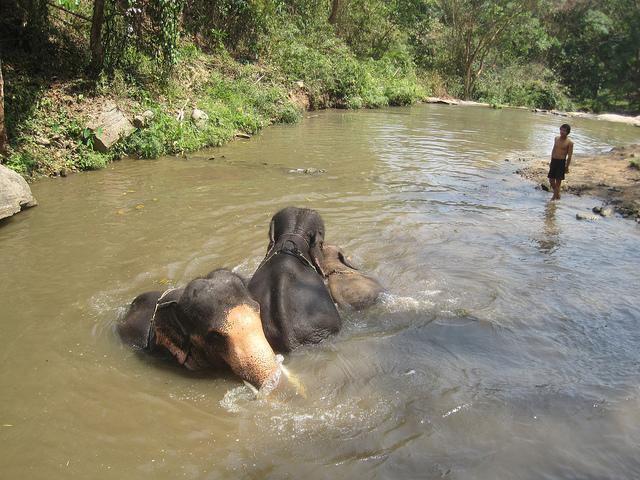How many elephants are in the picture?
Give a very brief answer. 3. 